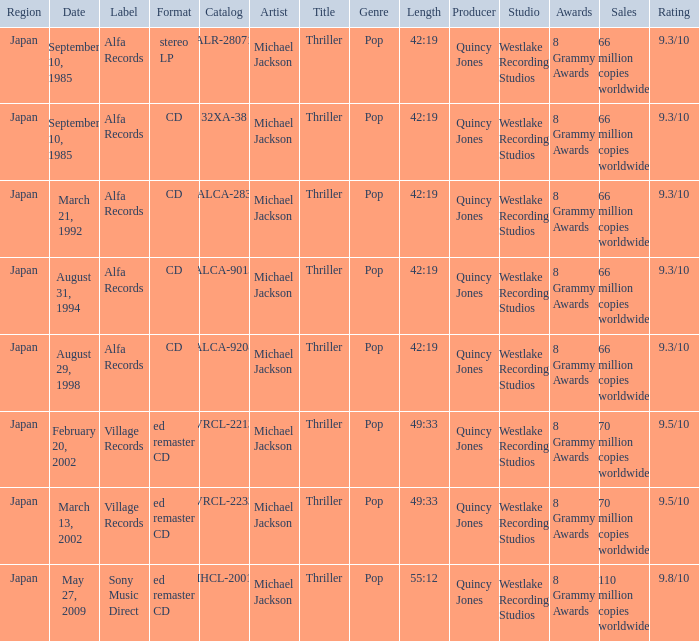Which identifier was recorded as alca-9013? Alfa Records. Would you mind parsing the complete table? {'header': ['Region', 'Date', 'Label', 'Format', 'Catalog', 'Artist', 'Title', 'Genre', 'Length', 'Producer', 'Studio', 'Awards', 'Sales', 'Rating'], 'rows': [['Japan', 'September 10, 1985', 'Alfa Records', 'stereo LP', 'ALR-28071', 'Michael Jackson', 'Thriller', 'Pop', '42:19', 'Quincy Jones', 'Westlake Recording Studios', '8 Grammy Awards', '66 million copies worldwide', '9.3/10'], ['Japan', 'September 10, 1985', 'Alfa Records', 'CD', '32XA-38', 'Michael Jackson', 'Thriller', 'Pop', '42:19', 'Quincy Jones', 'Westlake Recording Studios', '8 Grammy Awards', '66 million copies worldwide', '9.3/10'], ['Japan', 'March 21, 1992', 'Alfa Records', 'CD', 'ALCA-283', 'Michael Jackson', 'Thriller', 'Pop', '42:19', 'Quincy Jones', 'Westlake Recording Studios', '8 Grammy Awards', '66 million copies worldwide', '9.3/10'], ['Japan', 'August 31, 1994', 'Alfa Records', 'CD', 'ALCA-9013', 'Michael Jackson', 'Thriller', 'Pop', '42:19', 'Quincy Jones', 'Westlake Recording Studios', '8 Grammy Awards', '66 million copies worldwide', '9.3/10'], ['Japan', 'August 29, 1998', 'Alfa Records', 'CD', 'ALCA-9208', 'Michael Jackson', 'Thriller', 'Pop', '42:19', 'Quincy Jones', 'Westlake Recording Studios', '8 Grammy Awards', '66 million copies worldwide', '9.3/10'], ['Japan', 'February 20, 2002', 'Village Records', 'ed remaster CD', 'VRCL-2213', 'Michael Jackson', 'Thriller', 'Pop', '49:33', 'Quincy Jones', 'Westlake Recording Studios', '8 Grammy Awards', '70 million copies worldwide', '9.5/10'], ['Japan', 'March 13, 2002', 'Village Records', 'ed remaster CD', 'VRCL-2233', 'Michael Jackson', 'Thriller', 'Pop', '49:33', 'Quincy Jones', 'Westlake Recording Studios', '8 Grammy Awards', '70 million copies worldwide', '9.5/10'], ['Japan', 'May 27, 2009', 'Sony Music Direct', 'ed remaster CD', 'MHCL-20015', 'Michael Jackson', 'Thriller', 'Pop', '55:12', 'Quincy Jones', 'Westlake Recording Studios', '8 Grammy Awards', '110 million copies worldwide', '9.8/10']]} 